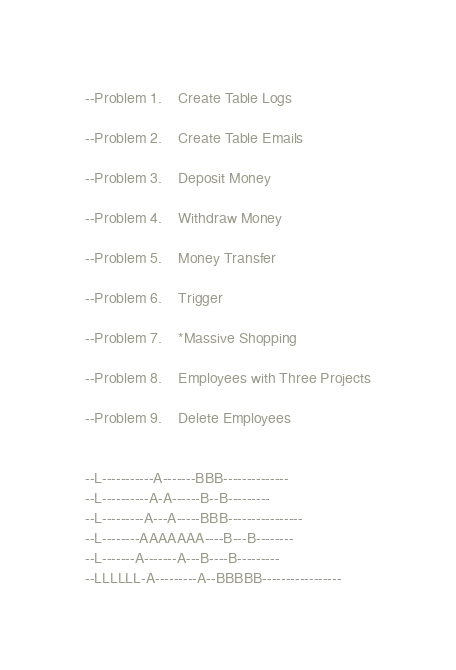Convert code to text. <code><loc_0><loc_0><loc_500><loc_500><_SQL_>--Problem 1.	Create Table Logs

--Problem 2.	Create Table Emails

--Problem 3.	Deposit Money

--Problem 4.	Withdraw Money

--Problem 5.	Money Transfer

--Problem 6.	Trigger

--Problem 7.	*Massive Shopping

--Problem 8.	Employees with Three Projects

--Problem 9.	Delete Employees


--L-----------A-------BBB--------------
--L----------A-A------B--B---------
--L---------A---A-----BBB----------------
--L--------AAAAAAA----B---B--------
--L-------A-------A---B----B---------
--LLLLLL-A---------A--BBBBB-----------------

</code> 